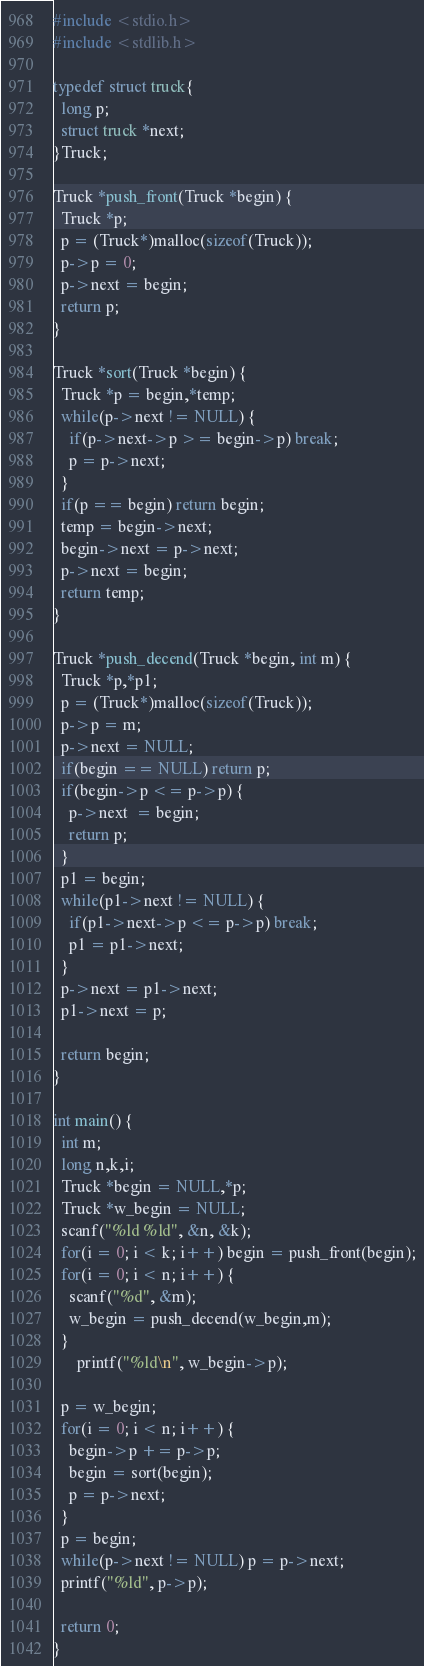Convert code to text. <code><loc_0><loc_0><loc_500><loc_500><_C_>#include <stdio.h>
#include <stdlib.h>

typedef struct truck{
  long p;
  struct truck *next;
}Truck;

Truck *push_front(Truck *begin) {
  Truck *p;
  p = (Truck*)malloc(sizeof(Truck));
  p->p = 0;
  p->next = begin;
  return p;
}

Truck *sort(Truck *begin) {
  Truck *p = begin,*temp;
  while(p->next != NULL) {
    if(p->next->p >= begin->p) break;
    p = p->next;
  }
  if(p == begin) return begin;
  temp = begin->next;
  begin->next = p->next;
  p->next = begin;
  return temp;
}

Truck *push_decend(Truck *begin, int m) {
  Truck *p,*p1;
  p = (Truck*)malloc(sizeof(Truck));
  p->p = m;
  p->next = NULL;
  if(begin == NULL) return p;
  if(begin->p <= p->p) {
    p->next  = begin;
    return p;
  }
  p1 = begin;
  while(p1->next != NULL) {
    if(p1->next->p <= p->p) break;
    p1 = p1->next;
  }
  p->next = p1->next;
  p1->next = p;
  
  return begin;
}

int main() {
  int m;
  long n,k,i;
  Truck *begin = NULL,*p;
  Truck *w_begin = NULL;
  scanf("%ld %ld", &n, &k);
  for(i = 0; i < k; i++) begin = push_front(begin);
  for(i = 0; i < n; i++) {
    scanf("%d", &m);
    w_begin = push_decend(w_begin,m);
  }
      printf("%ld\n", w_begin->p);

  p = w_begin;
  for(i = 0; i < n; i++) {
    begin->p += p->p;
    begin = sort(begin);
    p = p->next;
  }
  p = begin;
  while(p->next != NULL) p = p->next;
  printf("%ld", p->p);
   
  return 0;
}</code> 